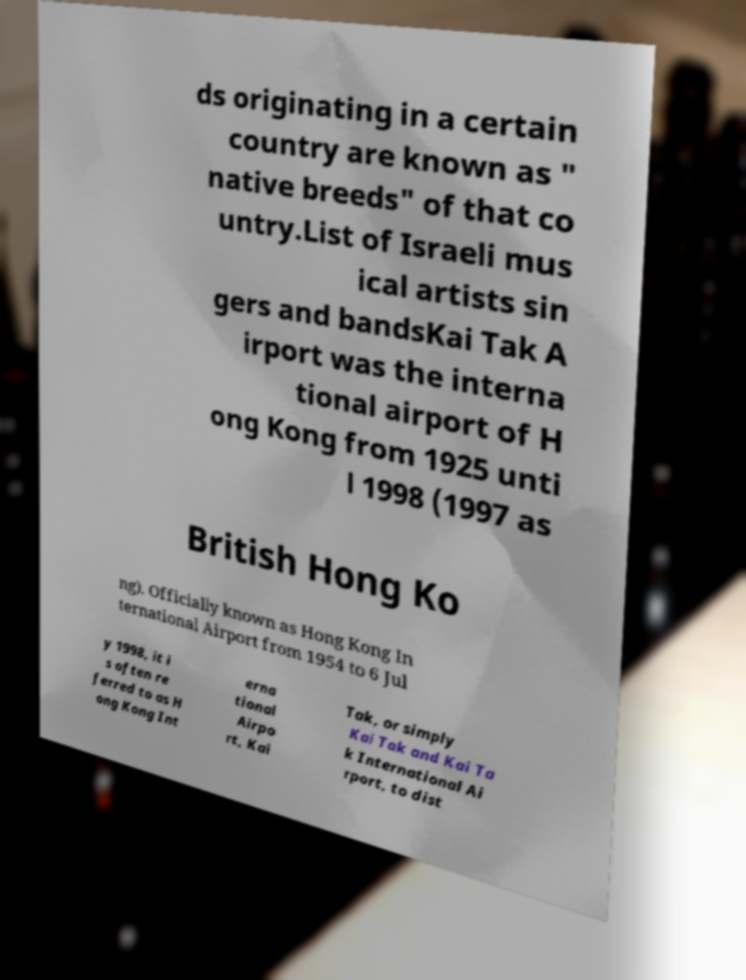Please identify and transcribe the text found in this image. ds originating in a certain country are known as " native breeds" of that co untry.List of Israeli mus ical artists sin gers and bandsKai Tak A irport was the interna tional airport of H ong Kong from 1925 unti l 1998 (1997 as British Hong Ko ng). Officially known as Hong Kong In ternational Airport from 1954 to 6 Jul y 1998, it i s often re ferred to as H ong Kong Int erna tional Airpo rt, Kai Tak, or simply Kai Tak and Kai Ta k International Ai rport, to dist 